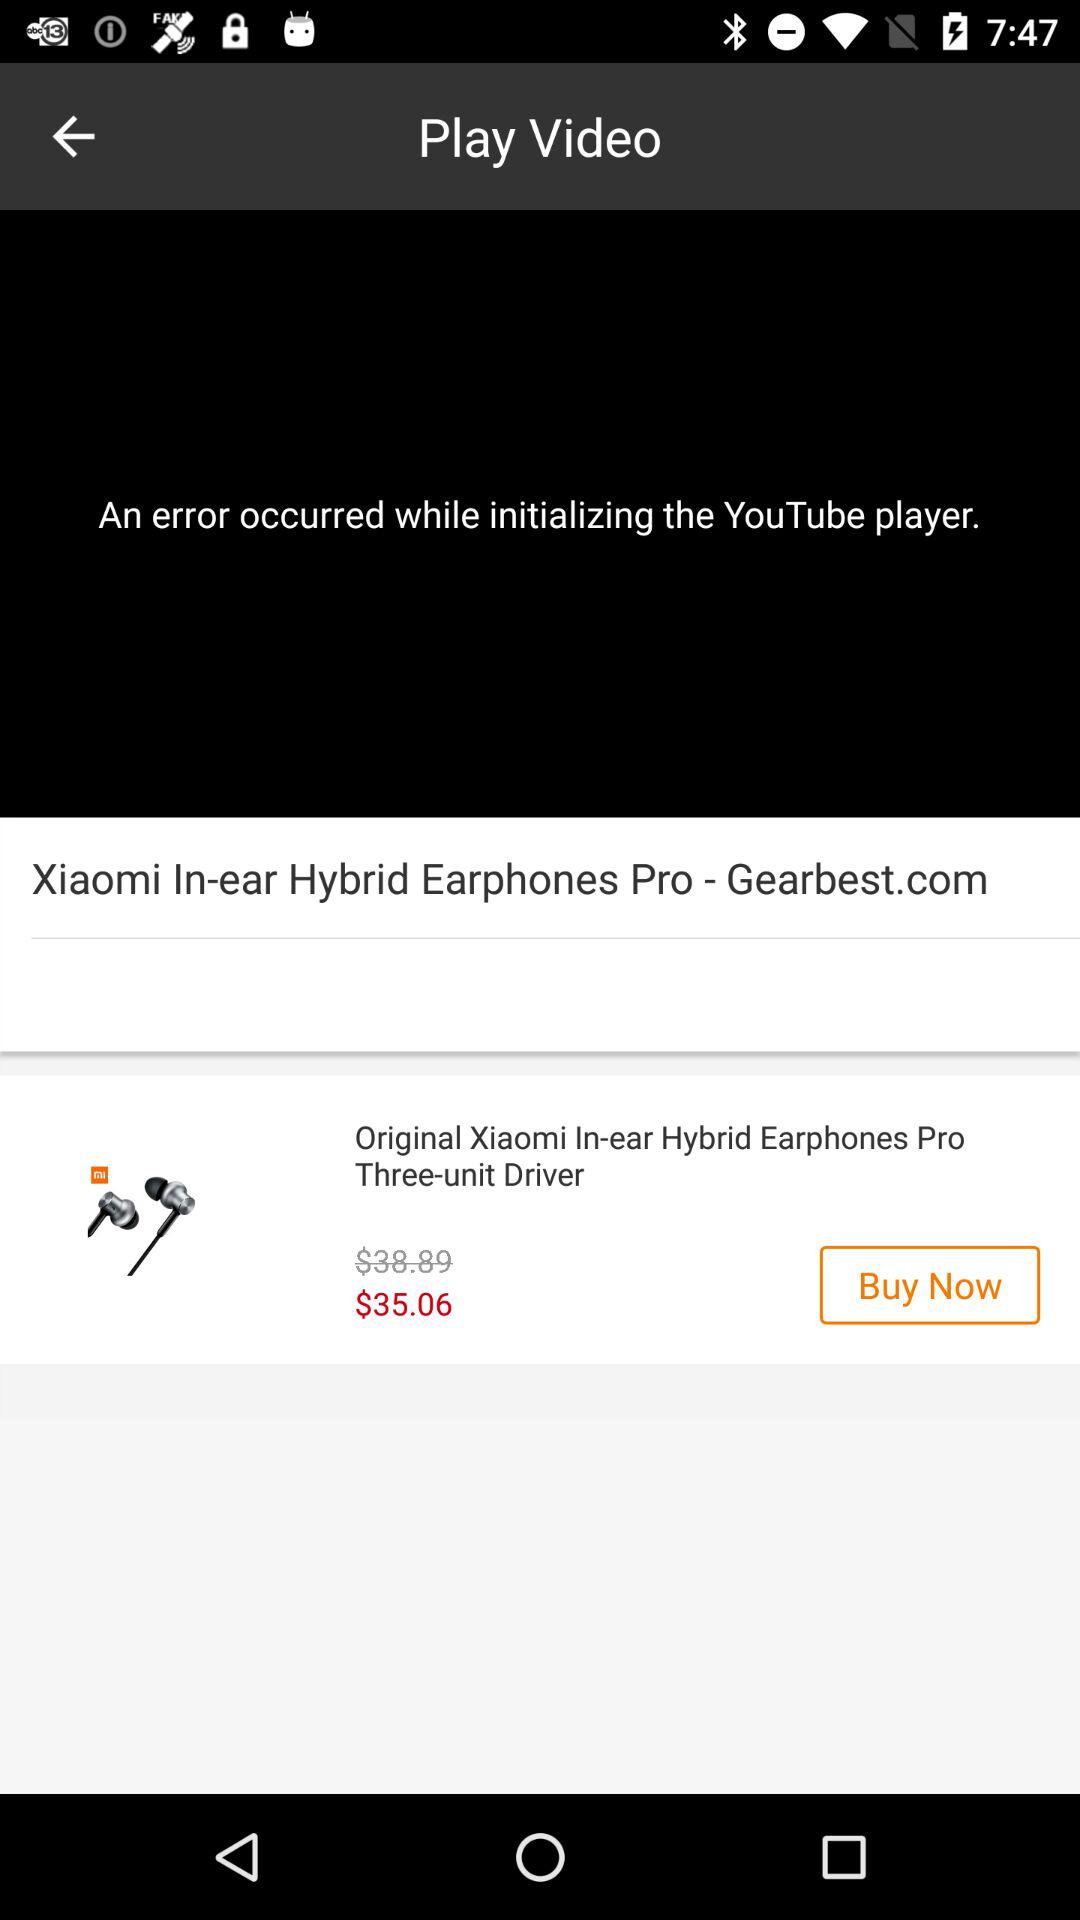How much cheaper is the Xiaomi In-ear Hybrid Earphones Pro than the original version?
Answer the question using a single word or phrase. $3.83 